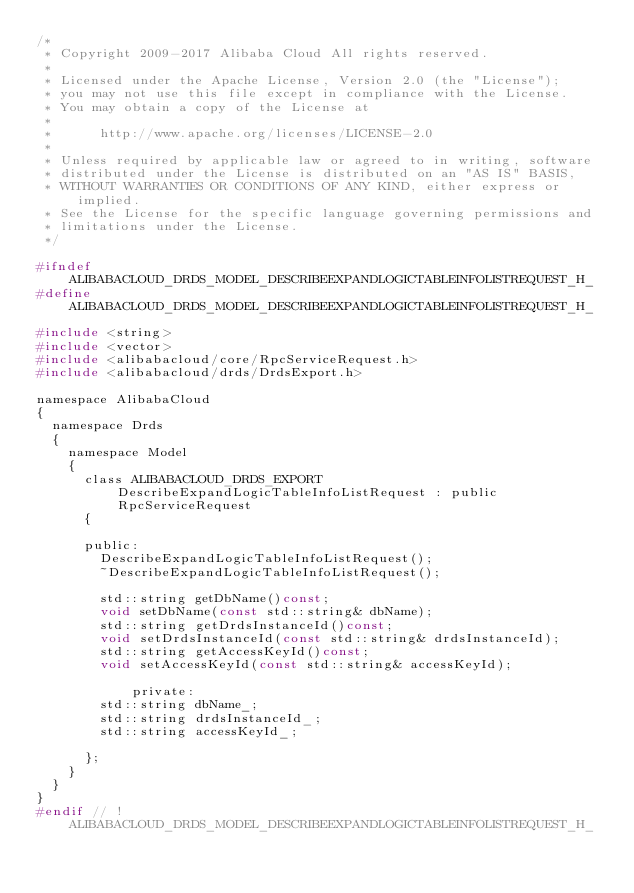<code> <loc_0><loc_0><loc_500><loc_500><_C_>/*
 * Copyright 2009-2017 Alibaba Cloud All rights reserved.
 * 
 * Licensed under the Apache License, Version 2.0 (the "License");
 * you may not use this file except in compliance with the License.
 * You may obtain a copy of the License at
 * 
 *      http://www.apache.org/licenses/LICENSE-2.0
 * 
 * Unless required by applicable law or agreed to in writing, software
 * distributed under the License is distributed on an "AS IS" BASIS,
 * WITHOUT WARRANTIES OR CONDITIONS OF ANY KIND, either express or implied.
 * See the License for the specific language governing permissions and
 * limitations under the License.
 */

#ifndef ALIBABACLOUD_DRDS_MODEL_DESCRIBEEXPANDLOGICTABLEINFOLISTREQUEST_H_
#define ALIBABACLOUD_DRDS_MODEL_DESCRIBEEXPANDLOGICTABLEINFOLISTREQUEST_H_

#include <string>
#include <vector>
#include <alibabacloud/core/RpcServiceRequest.h>
#include <alibabacloud/drds/DrdsExport.h>

namespace AlibabaCloud
{
	namespace Drds
	{
		namespace Model
		{
			class ALIBABACLOUD_DRDS_EXPORT DescribeExpandLogicTableInfoListRequest : public RpcServiceRequest
			{

			public:
				DescribeExpandLogicTableInfoListRequest();
				~DescribeExpandLogicTableInfoListRequest();

				std::string getDbName()const;
				void setDbName(const std::string& dbName);
				std::string getDrdsInstanceId()const;
				void setDrdsInstanceId(const std::string& drdsInstanceId);
				std::string getAccessKeyId()const;
				void setAccessKeyId(const std::string& accessKeyId);

            private:
				std::string dbName_;
				std::string drdsInstanceId_;
				std::string accessKeyId_;

			};
		}
	}
}
#endif // !ALIBABACLOUD_DRDS_MODEL_DESCRIBEEXPANDLOGICTABLEINFOLISTREQUEST_H_</code> 